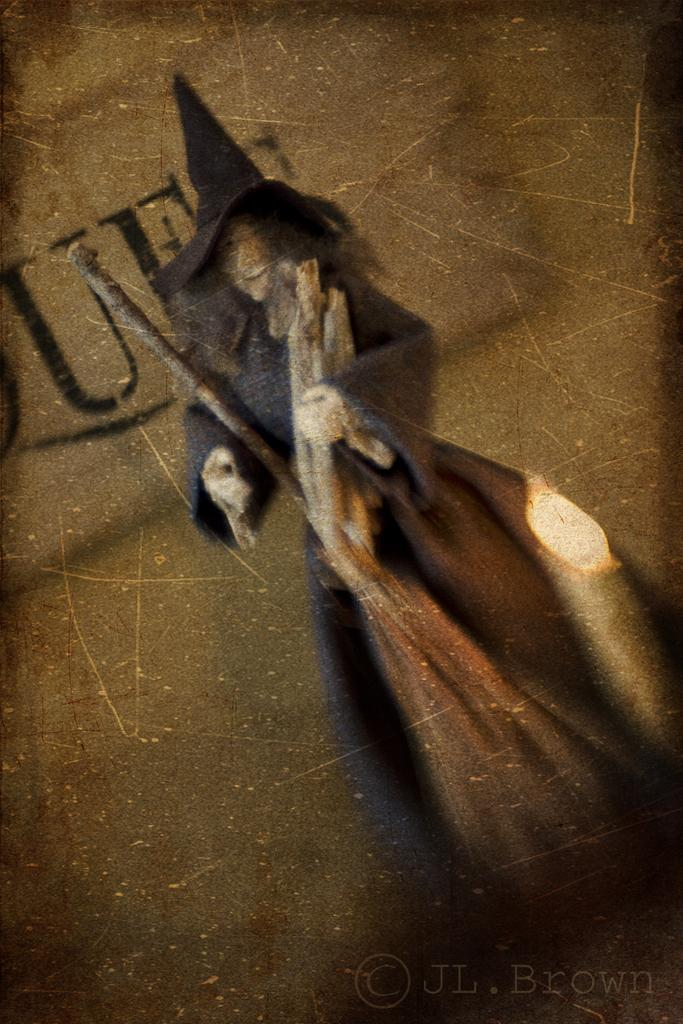What is the theme of the image in the picture? The theme of the image in the picture is Halloween. Can you describe any additional features of the Halloween image? There is text written on the back of the Halloween image. How does the dust affect the Halloween image in the picture? There is no mention of dust in the provided facts, so we cannot determine its effect on the Halloween image. 